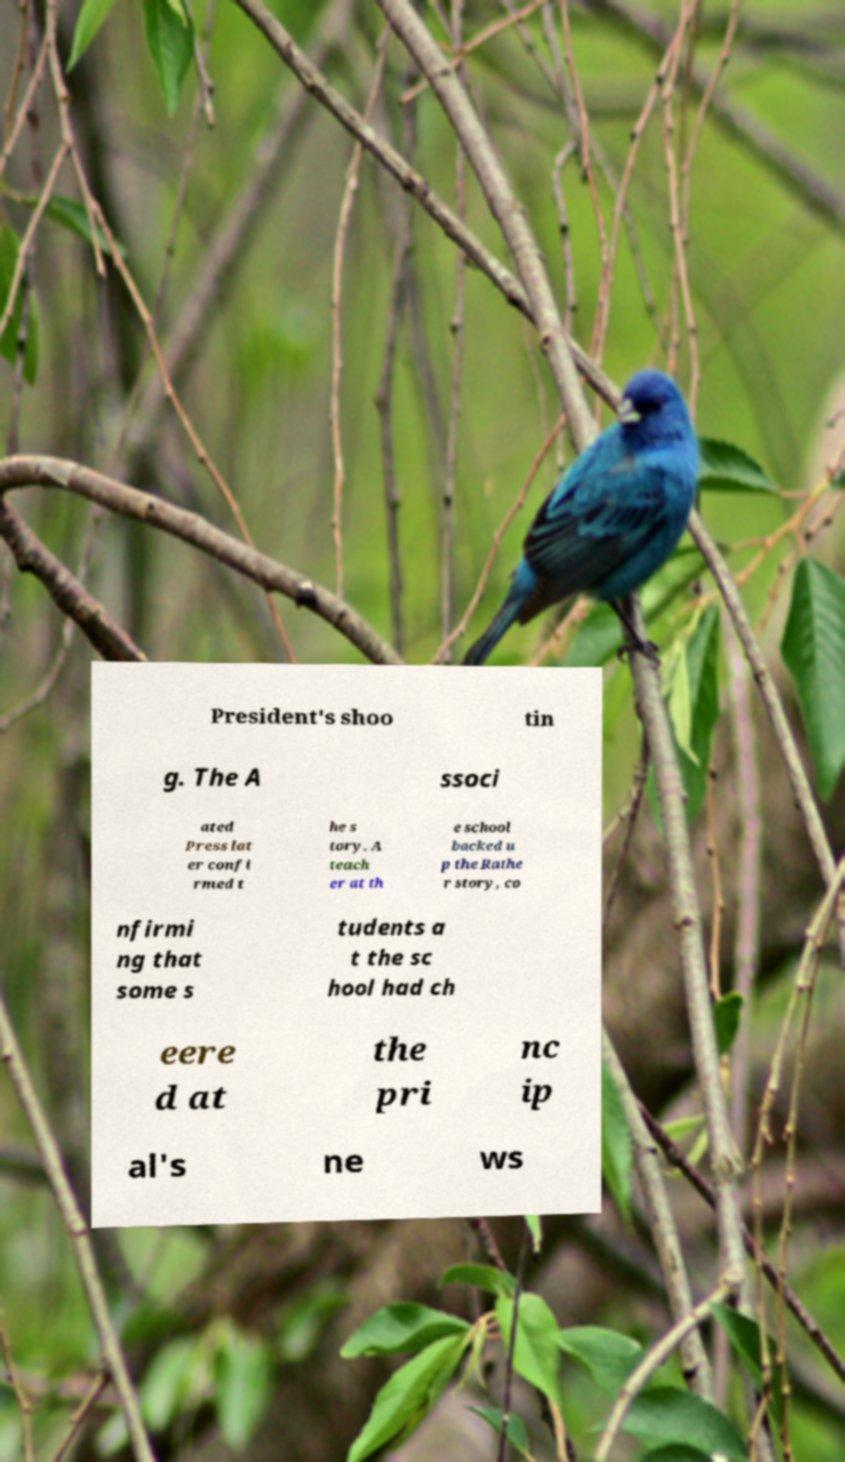What messages or text are displayed in this image? I need them in a readable, typed format. President's shoo tin g. The A ssoci ated Press lat er confi rmed t he s tory. A teach er at th e school backed u p the Rathe r story, co nfirmi ng that some s tudents a t the sc hool had ch eere d at the pri nc ip al's ne ws 